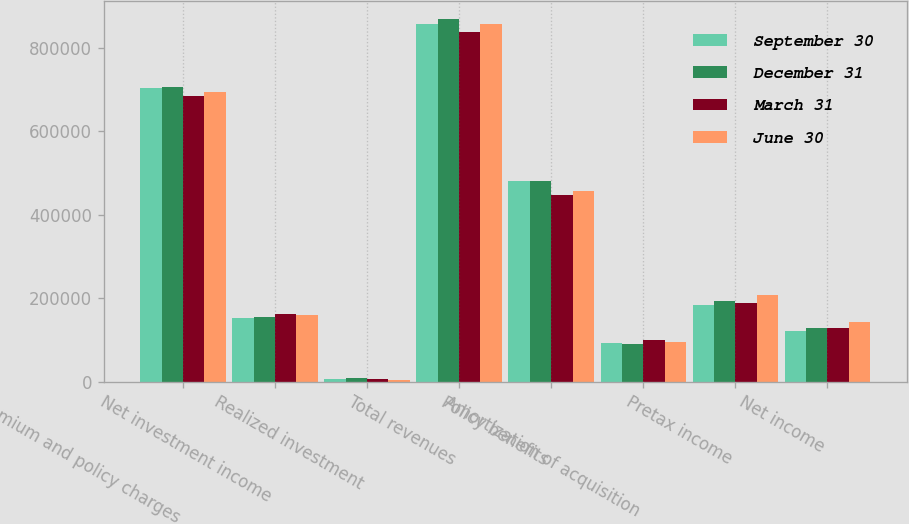Convert chart. <chart><loc_0><loc_0><loc_500><loc_500><stacked_bar_chart><ecel><fcel>Premium and policy charges<fcel>Net investment income<fcel>Realized investment<fcel>Total revenues<fcel>Policy benefits<fcel>Amortization of acquisition<fcel>Pretax income<fcel>Net income<nl><fcel>September 30<fcel>702677<fcel>153389<fcel>6196<fcel>857008<fcel>480154<fcel>92069<fcel>183971<fcel>120274<nl><fcel>December 31<fcel>705796<fcel>154925<fcel>7681<fcel>869135<fcel>480756<fcel>91172<fcel>194007<fcel>127375<nl><fcel>March 31<fcel>683657<fcel>160908<fcel>7299<fcel>837939<fcel>446052<fcel>100521<fcel>189273<fcel>128544<nl><fcel>June 30<fcel>692583<fcel>159524<fcel>4953<fcel>857096<fcel>456569<fcel>93728<fcel>206319<fcel>142438<nl></chart> 